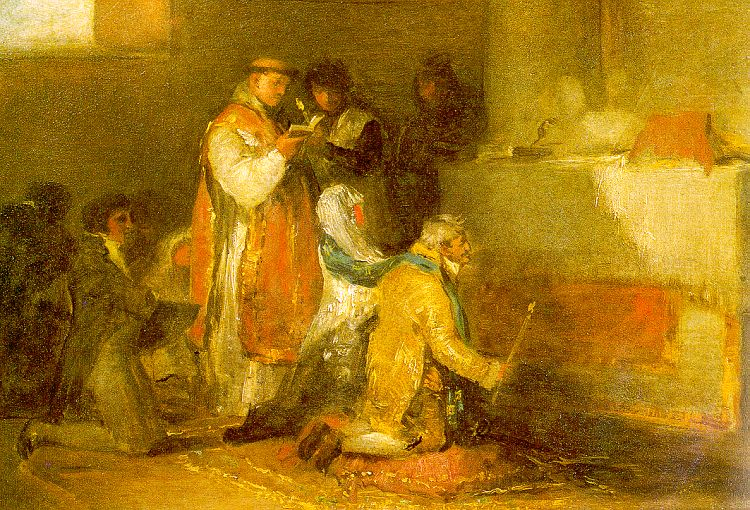Can you describe the expressions and postures of the people in this image? What might that tell us about the situation or their emotions? The expressions and postures in the image suggest a scene of quiet engagement and informal interaction among the figures. The central figures, one holding a book and several others gathered around, appear focused and involved in discussion or reading. The kneeling figure exudes a sense of attentiveness or perhaps servitude, indicative of social roles or tasks typical for the period. Their expressions, combined with their physical closeness, contribute to a feeling of communal life and shared pursuit, possibly in a domestic or scholarly setting. 